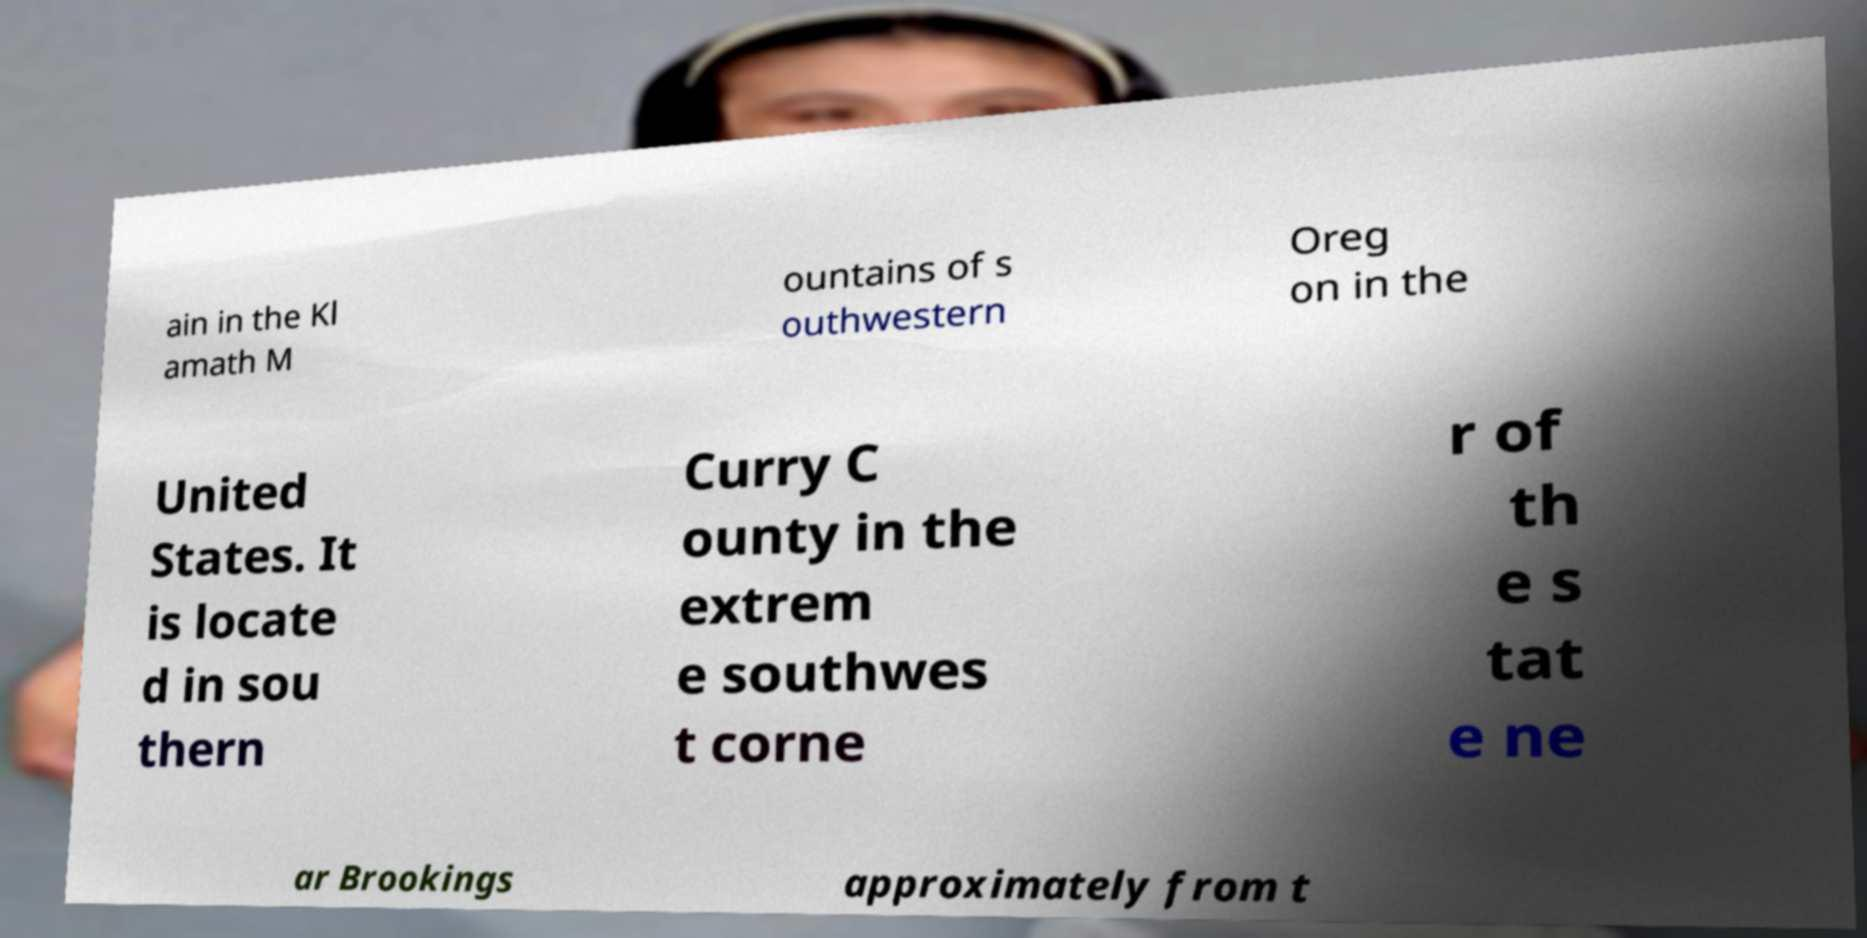There's text embedded in this image that I need extracted. Can you transcribe it verbatim? ain in the Kl amath M ountains of s outhwestern Oreg on in the United States. It is locate d in sou thern Curry C ounty in the extrem e southwes t corne r of th e s tat e ne ar Brookings approximately from t 